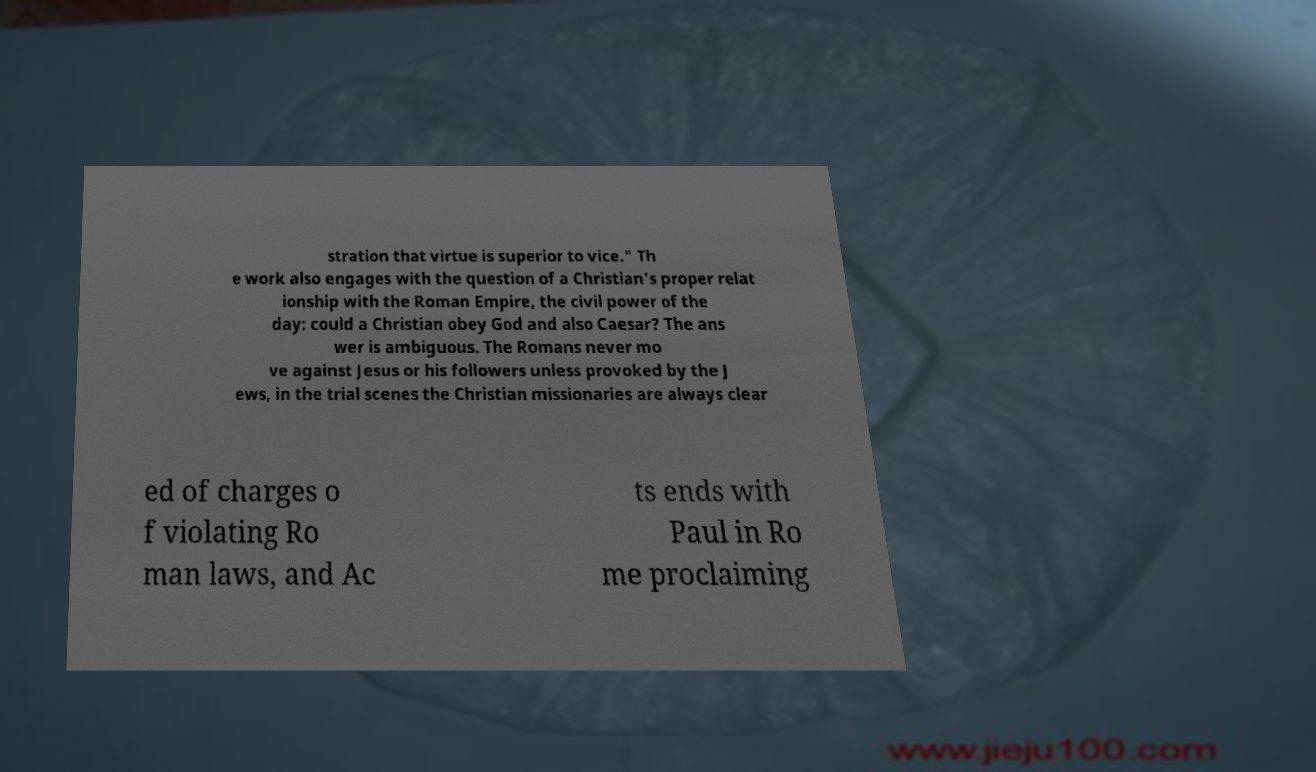For documentation purposes, I need the text within this image transcribed. Could you provide that? stration that virtue is superior to vice." Th e work also engages with the question of a Christian's proper relat ionship with the Roman Empire, the civil power of the day: could a Christian obey God and also Caesar? The ans wer is ambiguous. The Romans never mo ve against Jesus or his followers unless provoked by the J ews, in the trial scenes the Christian missionaries are always clear ed of charges o f violating Ro man laws, and Ac ts ends with Paul in Ro me proclaiming 